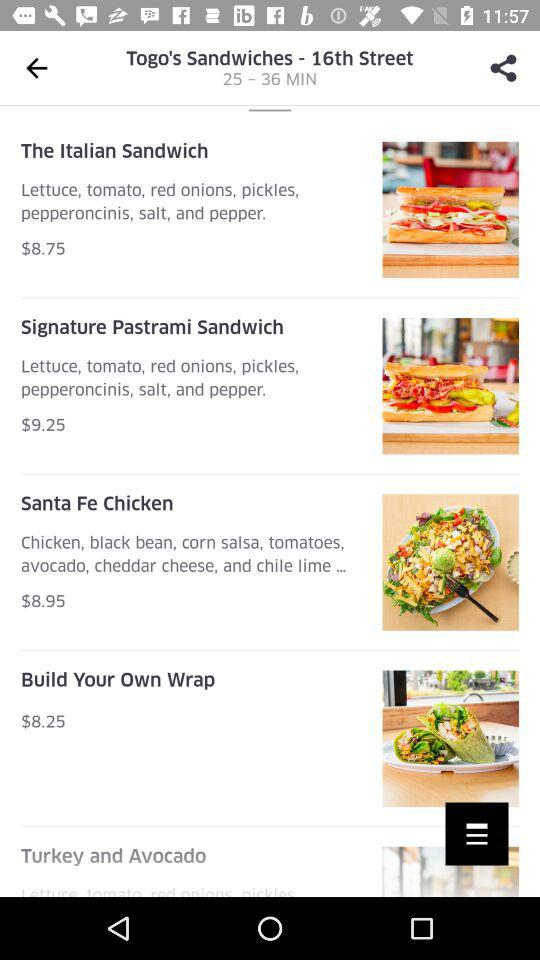What is the cost of a "Signature Pastrami Sandwich"? The cost is $9.25. 